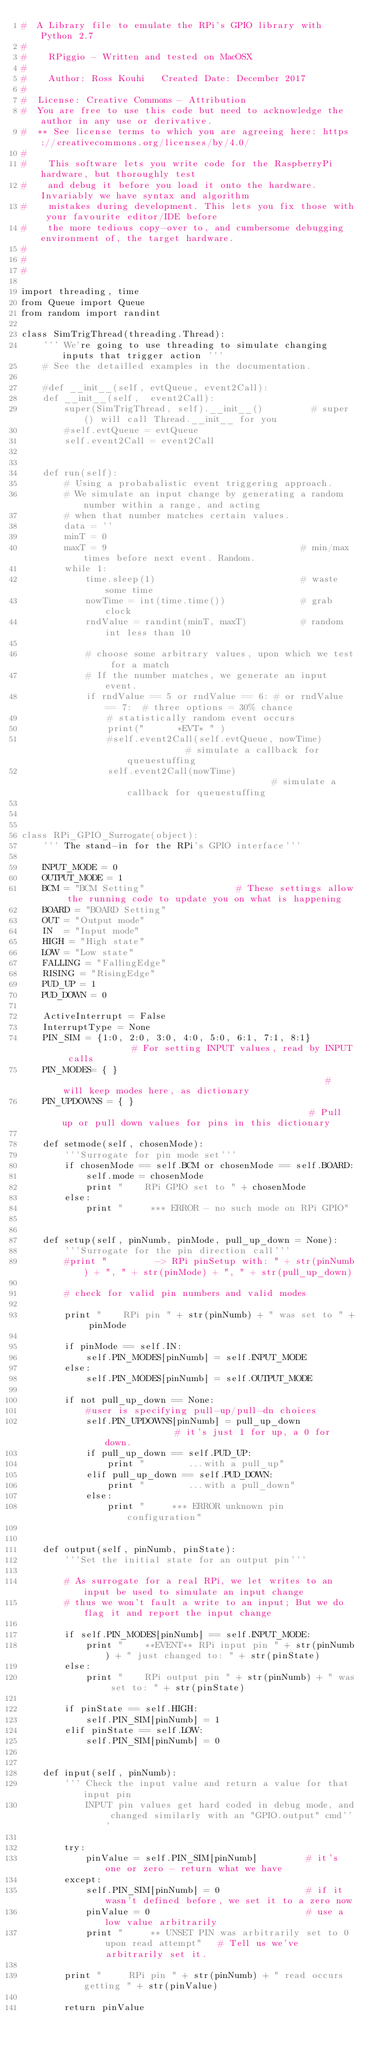<code> <loc_0><loc_0><loc_500><loc_500><_Python_>#  A Library file to emulate the RPi's GPIO library with Python 2.7
#
#    RPiggio - Written and tested on MacOSX
#
#    Author: Ross Kouhi   Created Date: December 2017
#
#  License: Creative Commons - Attribution
#  You are free to use this code but need to acknowledge the author in any use or derivative.
#  ** See license terms to which you are agreeing here: https://creativecommons.org/licenses/by/4.0/
#
#    This software lets you write code for the RaspberryPi hardware, but thoroughly test
#    and debug it before you load it onto the hardware. Invariably we have syntax and algorithm
#    mistakes during development. This lets you fix those with your favourite editor/IDE before
#    the more tedious copy-over to, and cumbersome debugging environment of, the target hardware.
#
#     
#

import threading, time
from Queue import Queue
from random import randint

class SimTrigThread(threading.Thread):
    ''' We're going to use threading to simulate changing inputs that trigger action '''
    # See the detailled examples in the documentation.

    #def __init__(self, evtQueue, event2Call):
    def __init__(self,  event2Call):
        super(SimTrigThread, self).__init__()         # super() will call Thread.__init__ for you
        #self.evtQueue = evtQueue
        self.event2Call = event2Call


    def run(self):
        # Using a probabalistic event triggering approach.
        # We simulate an input change by generating a random number within a range, and acting
        # when that number matches certain values.
        data = ''
        minT = 0
        maxT = 9                                    # min/max times before next event. Random.
        while 1:
            time.sleep(1)                           # waste some time
            nowTime = int(time.time())              # grab clock
            rndValue = randint(minT, maxT)          # random int less than 10

            # choose some arbitrary values, upon which we test for a match
            # If the number matches, we generate an input event.
            if rndValue == 5 or rndValue == 6: # or rndValue == 7:  # three options = 30% chance
                # statistically random event occurs
                print("      *EVT* " )
                #self.event2Call(self.evtQueue, nowTime)            # simulate a callback for queuestuffing
                self.event2Call(nowTime)                            # simulate a callback for queuestuffing



class RPi_GPIO_Surrogate(object):
    ''' The stand-in for the RPi's GPIO interface'''

    INPUT_MODE = 0
    OUTPUT_MODE = 1
    BCM = "BCM Setting"                 # These settings allow the running code to update you on what is happening
    BOARD = "BOARD Setting"
    OUT = "Output mode"
    IN  = "Input mode"
    HIGH = "High state"
    LOW = "Low state"
    FALLING = "FallingEdge"
    RISING = "RisingEdge"
    PUD_UP = 1
    PUD_DOWN = 0

    ActiveInterrupt = False
    InterruptType = None
    PIN_SIM = {1:0, 2:0, 3:0, 4:0, 5:0, 6:1, 7:1, 8:1}              # For setting INPUT values, read by INPUT calls
    PIN_MODES= { }                                                  # will keep modes here, as dictionary
    PIN_UPDOWNS = { }                                               # Pull up or pull down values for pins in this dictionary

    def setmode(self, chosenMode):
        '''Surrogate for pin mode set'''
        if chosenMode == self.BCM or chosenMode == self.BOARD:
            self.mode = chosenMode
            print "    RPi GPIO set to " + chosenMode
        else:
            print "     *** ERROR - no such mode on RPi GPIO"


    def setup(self, pinNumb, pinMode, pull_up_down = None):
        '''Surrogate for the pin direction call'''
        #print "         -> RPi pinSetup with: " + str(pinNumb) + ", " + str(pinMode) + ", " + str(pull_up_down)

        # check for valid pin numbers and valid modes

        print "    RPi pin " + str(pinNumb) + " was set to " + pinMode

        if pinMode == self.IN:
            self.PIN_MODES[pinNumb] = self.INPUT_MODE
        else:
            self.PIN_MODES[pinNumb] = self.OUTPUT_MODE

        if not pull_up_down == None:
            #user is specifying pull-up/pull-dn choices
            self.PIN_UPDOWNS[pinNumb] = pull_up_down              # it's just 1 for up, a 0 for down.
            if pull_up_down == self.PUD_UP:
                print "        ...with a pull_up"
            elif pull_up_down == self.PUD_DOWN:
                print "        ...with a pull_down"
            else:
                print "     *** ERROR unknown pin configuration"


    def output(self, pinNumb, pinState):
        '''Set the initial state for an output pin'''

        # As surrogate for a real RPi, we let writes to an input be used to simulate an input change
        # thus we won't fault a write to an input; But we do flag it and report the input change

        if self.PIN_MODES[pinNumb] == self.INPUT_MODE:
            print "    **EVENT** RPi input pin " + str(pinNumb) + " just changed to: " + str(pinState)
        else:
            print "    RPi output pin " + str(pinNumb) + " was set to: " + str(pinState)

        if pinState == self.HIGH:
            self.PIN_SIM[pinNumb] = 1
        elif pinState == self.LOW:
            self.PIN_SIM[pinNumb] = 0


    def input(self, pinNumb):
        ''' Check the input value and return a value for that input pin
            INPUT pin values get hard coded in debug mode, and changed similarly with an "GPIO.output" cmd'''

        try:
            pinValue = self.PIN_SIM[pinNumb]         # it's one or zero - return what we have
        except:
            self.PIN_SIM[pinNumb] = 0                # if it wasn't defined before, we set it to a zero now
            pinValue = 0                             # use a low value arbitrarily
            print "     ** UNSET PIN was arbitrarily set to 0 upon read attempt"   # Tell us we've arbitrarily set it.

        print "     RPi pin " + str(pinNumb) + " read occurs getting " + str(pinValue)

        return pinValue
</code> 